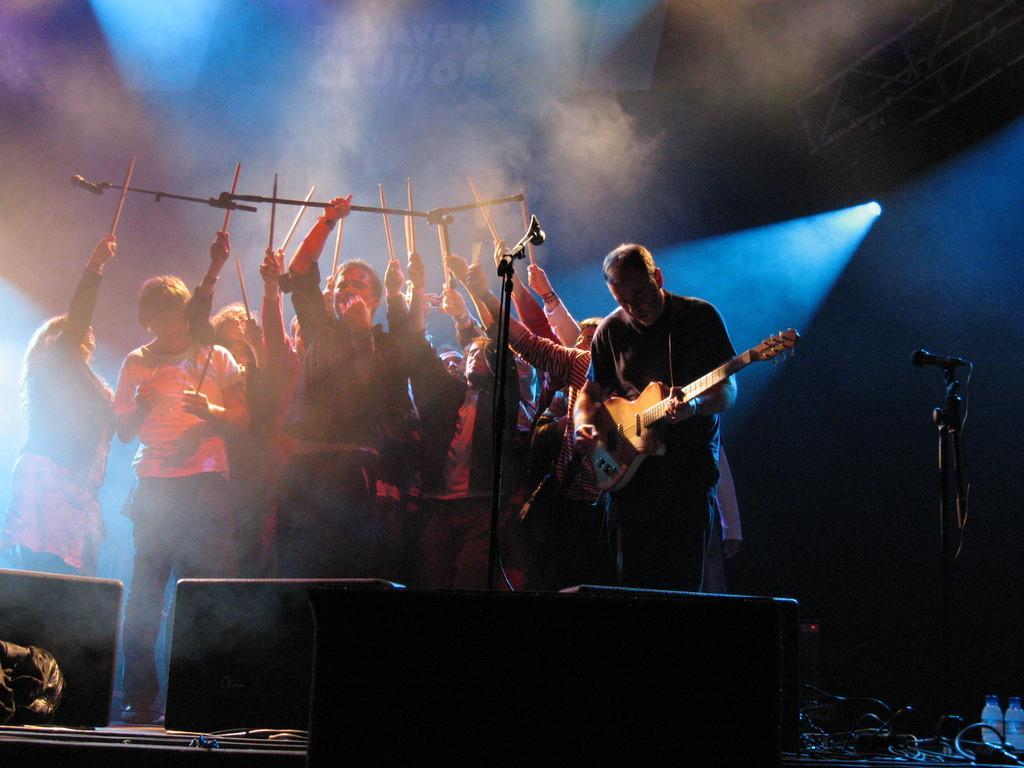Please provide a concise description of this image. There are many persons standing holding sticks. A person in the right side is holding guitar and playing. There are mic stands. In the front there are speakers. 